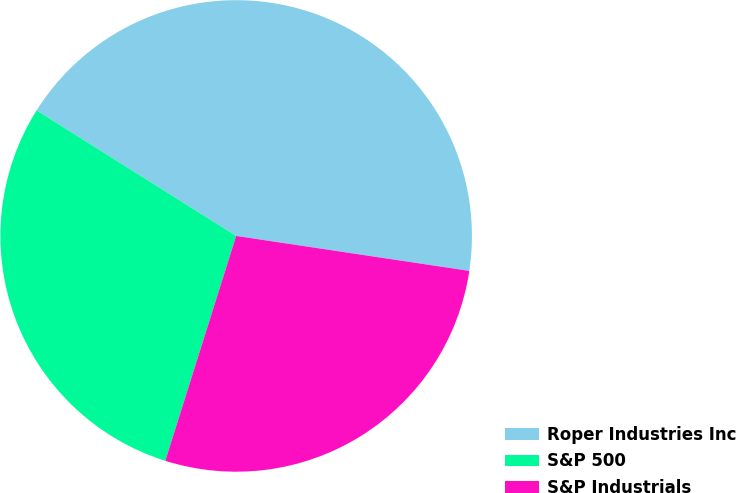Convert chart to OTSL. <chart><loc_0><loc_0><loc_500><loc_500><pie_chart><fcel>Roper Industries Inc<fcel>S&P 500<fcel>S&P Industrials<nl><fcel>43.43%<fcel>29.08%<fcel>27.49%<nl></chart> 